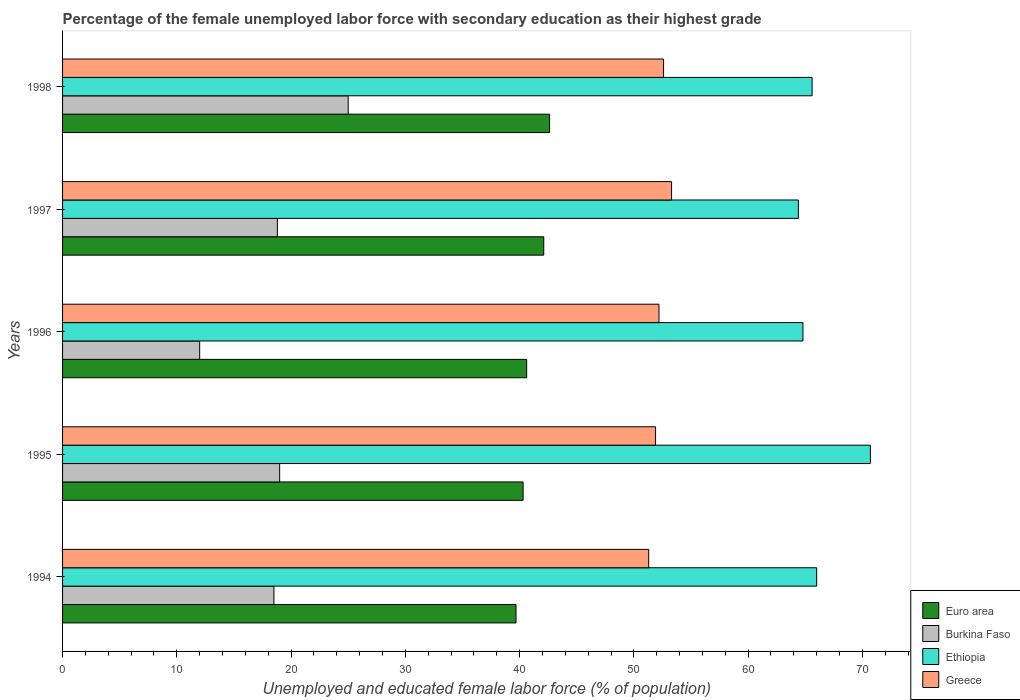How many groups of bars are there?
Ensure brevity in your answer.  5. Are the number of bars per tick equal to the number of legend labels?
Offer a terse response. Yes. How many bars are there on the 4th tick from the bottom?
Keep it short and to the point. 4. What is the label of the 4th group of bars from the top?
Offer a terse response. 1995. Across all years, what is the maximum percentage of the unemployed female labor force with secondary education in Greece?
Your answer should be compact. 53.3. Across all years, what is the minimum percentage of the unemployed female labor force with secondary education in Burkina Faso?
Make the answer very short. 12. In which year was the percentage of the unemployed female labor force with secondary education in Burkina Faso maximum?
Give a very brief answer. 1998. In which year was the percentage of the unemployed female labor force with secondary education in Greece minimum?
Offer a terse response. 1994. What is the total percentage of the unemployed female labor force with secondary education in Euro area in the graph?
Provide a short and direct response. 205.35. What is the difference between the percentage of the unemployed female labor force with secondary education in Euro area in 1994 and that in 1997?
Offer a very short reply. -2.43. What is the difference between the percentage of the unemployed female labor force with secondary education in Euro area in 1996 and the percentage of the unemployed female labor force with secondary education in Burkina Faso in 1997?
Your response must be concise. 21.82. What is the average percentage of the unemployed female labor force with secondary education in Euro area per year?
Provide a short and direct response. 41.07. In the year 1996, what is the difference between the percentage of the unemployed female labor force with secondary education in Euro area and percentage of the unemployed female labor force with secondary education in Burkina Faso?
Your answer should be very brief. 28.62. In how many years, is the percentage of the unemployed female labor force with secondary education in Greece greater than 2 %?
Give a very brief answer. 5. What is the ratio of the percentage of the unemployed female labor force with secondary education in Euro area in 1994 to that in 1996?
Provide a succinct answer. 0.98. What is the difference between the highest and the second highest percentage of the unemployed female labor force with secondary education in Burkina Faso?
Your response must be concise. 6. Is the sum of the percentage of the unemployed female labor force with secondary education in Greece in 1994 and 1997 greater than the maximum percentage of the unemployed female labor force with secondary education in Euro area across all years?
Give a very brief answer. Yes. Is it the case that in every year, the sum of the percentage of the unemployed female labor force with secondary education in Burkina Faso and percentage of the unemployed female labor force with secondary education in Ethiopia is greater than the sum of percentage of the unemployed female labor force with secondary education in Greece and percentage of the unemployed female labor force with secondary education in Euro area?
Ensure brevity in your answer.  Yes. What does the 2nd bar from the top in 1997 represents?
Keep it short and to the point. Ethiopia. What does the 3rd bar from the bottom in 1995 represents?
Your answer should be compact. Ethiopia. Is it the case that in every year, the sum of the percentage of the unemployed female labor force with secondary education in Ethiopia and percentage of the unemployed female labor force with secondary education in Burkina Faso is greater than the percentage of the unemployed female labor force with secondary education in Greece?
Your answer should be very brief. Yes. How many years are there in the graph?
Your response must be concise. 5. How are the legend labels stacked?
Ensure brevity in your answer.  Vertical. What is the title of the graph?
Your answer should be very brief. Percentage of the female unemployed labor force with secondary education as their highest grade. Does "Saudi Arabia" appear as one of the legend labels in the graph?
Your answer should be compact. No. What is the label or title of the X-axis?
Ensure brevity in your answer.  Unemployed and educated female labor force (% of population). What is the Unemployed and educated female labor force (% of population) of Euro area in 1994?
Give a very brief answer. 39.69. What is the Unemployed and educated female labor force (% of population) in Burkina Faso in 1994?
Offer a terse response. 18.5. What is the Unemployed and educated female labor force (% of population) in Greece in 1994?
Your answer should be compact. 51.3. What is the Unemployed and educated female labor force (% of population) of Euro area in 1995?
Offer a terse response. 40.31. What is the Unemployed and educated female labor force (% of population) in Ethiopia in 1995?
Give a very brief answer. 70.7. What is the Unemployed and educated female labor force (% of population) of Greece in 1995?
Offer a terse response. 51.9. What is the Unemployed and educated female labor force (% of population) of Euro area in 1996?
Make the answer very short. 40.62. What is the Unemployed and educated female labor force (% of population) of Ethiopia in 1996?
Your answer should be compact. 64.8. What is the Unemployed and educated female labor force (% of population) in Greece in 1996?
Provide a succinct answer. 52.2. What is the Unemployed and educated female labor force (% of population) of Euro area in 1997?
Make the answer very short. 42.11. What is the Unemployed and educated female labor force (% of population) of Burkina Faso in 1997?
Ensure brevity in your answer.  18.8. What is the Unemployed and educated female labor force (% of population) of Ethiopia in 1997?
Keep it short and to the point. 64.4. What is the Unemployed and educated female labor force (% of population) of Greece in 1997?
Give a very brief answer. 53.3. What is the Unemployed and educated female labor force (% of population) of Euro area in 1998?
Your answer should be very brief. 42.63. What is the Unemployed and educated female labor force (% of population) in Burkina Faso in 1998?
Your response must be concise. 25. What is the Unemployed and educated female labor force (% of population) of Ethiopia in 1998?
Provide a succinct answer. 65.6. What is the Unemployed and educated female labor force (% of population) in Greece in 1998?
Your response must be concise. 52.6. Across all years, what is the maximum Unemployed and educated female labor force (% of population) in Euro area?
Provide a short and direct response. 42.63. Across all years, what is the maximum Unemployed and educated female labor force (% of population) of Burkina Faso?
Make the answer very short. 25. Across all years, what is the maximum Unemployed and educated female labor force (% of population) of Ethiopia?
Provide a short and direct response. 70.7. Across all years, what is the maximum Unemployed and educated female labor force (% of population) in Greece?
Offer a terse response. 53.3. Across all years, what is the minimum Unemployed and educated female labor force (% of population) in Euro area?
Offer a terse response. 39.69. Across all years, what is the minimum Unemployed and educated female labor force (% of population) in Ethiopia?
Your response must be concise. 64.4. Across all years, what is the minimum Unemployed and educated female labor force (% of population) of Greece?
Provide a short and direct response. 51.3. What is the total Unemployed and educated female labor force (% of population) in Euro area in the graph?
Provide a short and direct response. 205.35. What is the total Unemployed and educated female labor force (% of population) in Burkina Faso in the graph?
Offer a terse response. 93.3. What is the total Unemployed and educated female labor force (% of population) in Ethiopia in the graph?
Your answer should be very brief. 331.5. What is the total Unemployed and educated female labor force (% of population) of Greece in the graph?
Your answer should be very brief. 261.3. What is the difference between the Unemployed and educated female labor force (% of population) in Euro area in 1994 and that in 1995?
Provide a short and direct response. -0.62. What is the difference between the Unemployed and educated female labor force (% of population) in Ethiopia in 1994 and that in 1995?
Your answer should be very brief. -4.7. What is the difference between the Unemployed and educated female labor force (% of population) in Euro area in 1994 and that in 1996?
Your response must be concise. -0.93. What is the difference between the Unemployed and educated female labor force (% of population) of Euro area in 1994 and that in 1997?
Offer a very short reply. -2.43. What is the difference between the Unemployed and educated female labor force (% of population) in Ethiopia in 1994 and that in 1997?
Make the answer very short. 1.6. What is the difference between the Unemployed and educated female labor force (% of population) of Euro area in 1994 and that in 1998?
Offer a very short reply. -2.94. What is the difference between the Unemployed and educated female labor force (% of population) of Ethiopia in 1994 and that in 1998?
Your answer should be very brief. 0.4. What is the difference between the Unemployed and educated female labor force (% of population) in Euro area in 1995 and that in 1996?
Your answer should be compact. -0.31. What is the difference between the Unemployed and educated female labor force (% of population) of Burkina Faso in 1995 and that in 1996?
Your answer should be compact. 7. What is the difference between the Unemployed and educated female labor force (% of population) in Ethiopia in 1995 and that in 1996?
Keep it short and to the point. 5.9. What is the difference between the Unemployed and educated female labor force (% of population) of Euro area in 1995 and that in 1997?
Make the answer very short. -1.81. What is the difference between the Unemployed and educated female labor force (% of population) of Burkina Faso in 1995 and that in 1997?
Provide a succinct answer. 0.2. What is the difference between the Unemployed and educated female labor force (% of population) of Greece in 1995 and that in 1997?
Your answer should be very brief. -1.4. What is the difference between the Unemployed and educated female labor force (% of population) in Euro area in 1995 and that in 1998?
Your answer should be compact. -2.32. What is the difference between the Unemployed and educated female labor force (% of population) in Ethiopia in 1995 and that in 1998?
Provide a short and direct response. 5.1. What is the difference between the Unemployed and educated female labor force (% of population) of Euro area in 1996 and that in 1997?
Your answer should be compact. -1.49. What is the difference between the Unemployed and educated female labor force (% of population) of Burkina Faso in 1996 and that in 1997?
Provide a short and direct response. -6.8. What is the difference between the Unemployed and educated female labor force (% of population) of Euro area in 1996 and that in 1998?
Provide a short and direct response. -2.01. What is the difference between the Unemployed and educated female labor force (% of population) of Burkina Faso in 1996 and that in 1998?
Provide a short and direct response. -13. What is the difference between the Unemployed and educated female labor force (% of population) in Ethiopia in 1996 and that in 1998?
Give a very brief answer. -0.8. What is the difference between the Unemployed and educated female labor force (% of population) of Euro area in 1997 and that in 1998?
Provide a short and direct response. -0.51. What is the difference between the Unemployed and educated female labor force (% of population) in Burkina Faso in 1997 and that in 1998?
Provide a succinct answer. -6.2. What is the difference between the Unemployed and educated female labor force (% of population) of Greece in 1997 and that in 1998?
Ensure brevity in your answer.  0.7. What is the difference between the Unemployed and educated female labor force (% of population) in Euro area in 1994 and the Unemployed and educated female labor force (% of population) in Burkina Faso in 1995?
Make the answer very short. 20.69. What is the difference between the Unemployed and educated female labor force (% of population) of Euro area in 1994 and the Unemployed and educated female labor force (% of population) of Ethiopia in 1995?
Offer a terse response. -31.01. What is the difference between the Unemployed and educated female labor force (% of population) in Euro area in 1994 and the Unemployed and educated female labor force (% of population) in Greece in 1995?
Offer a very short reply. -12.21. What is the difference between the Unemployed and educated female labor force (% of population) in Burkina Faso in 1994 and the Unemployed and educated female labor force (% of population) in Ethiopia in 1995?
Give a very brief answer. -52.2. What is the difference between the Unemployed and educated female labor force (% of population) in Burkina Faso in 1994 and the Unemployed and educated female labor force (% of population) in Greece in 1995?
Your answer should be very brief. -33.4. What is the difference between the Unemployed and educated female labor force (% of population) in Ethiopia in 1994 and the Unemployed and educated female labor force (% of population) in Greece in 1995?
Make the answer very short. 14.1. What is the difference between the Unemployed and educated female labor force (% of population) in Euro area in 1994 and the Unemployed and educated female labor force (% of population) in Burkina Faso in 1996?
Offer a very short reply. 27.69. What is the difference between the Unemployed and educated female labor force (% of population) of Euro area in 1994 and the Unemployed and educated female labor force (% of population) of Ethiopia in 1996?
Ensure brevity in your answer.  -25.11. What is the difference between the Unemployed and educated female labor force (% of population) of Euro area in 1994 and the Unemployed and educated female labor force (% of population) of Greece in 1996?
Give a very brief answer. -12.51. What is the difference between the Unemployed and educated female labor force (% of population) in Burkina Faso in 1994 and the Unemployed and educated female labor force (% of population) in Ethiopia in 1996?
Provide a short and direct response. -46.3. What is the difference between the Unemployed and educated female labor force (% of population) in Burkina Faso in 1994 and the Unemployed and educated female labor force (% of population) in Greece in 1996?
Your response must be concise. -33.7. What is the difference between the Unemployed and educated female labor force (% of population) of Ethiopia in 1994 and the Unemployed and educated female labor force (% of population) of Greece in 1996?
Your answer should be compact. 13.8. What is the difference between the Unemployed and educated female labor force (% of population) of Euro area in 1994 and the Unemployed and educated female labor force (% of population) of Burkina Faso in 1997?
Make the answer very short. 20.89. What is the difference between the Unemployed and educated female labor force (% of population) in Euro area in 1994 and the Unemployed and educated female labor force (% of population) in Ethiopia in 1997?
Your answer should be very brief. -24.71. What is the difference between the Unemployed and educated female labor force (% of population) of Euro area in 1994 and the Unemployed and educated female labor force (% of population) of Greece in 1997?
Offer a terse response. -13.61. What is the difference between the Unemployed and educated female labor force (% of population) in Burkina Faso in 1994 and the Unemployed and educated female labor force (% of population) in Ethiopia in 1997?
Keep it short and to the point. -45.9. What is the difference between the Unemployed and educated female labor force (% of population) of Burkina Faso in 1994 and the Unemployed and educated female labor force (% of population) of Greece in 1997?
Offer a terse response. -34.8. What is the difference between the Unemployed and educated female labor force (% of population) of Ethiopia in 1994 and the Unemployed and educated female labor force (% of population) of Greece in 1997?
Provide a short and direct response. 12.7. What is the difference between the Unemployed and educated female labor force (% of population) in Euro area in 1994 and the Unemployed and educated female labor force (% of population) in Burkina Faso in 1998?
Make the answer very short. 14.69. What is the difference between the Unemployed and educated female labor force (% of population) in Euro area in 1994 and the Unemployed and educated female labor force (% of population) in Ethiopia in 1998?
Your response must be concise. -25.91. What is the difference between the Unemployed and educated female labor force (% of population) in Euro area in 1994 and the Unemployed and educated female labor force (% of population) in Greece in 1998?
Your answer should be very brief. -12.91. What is the difference between the Unemployed and educated female labor force (% of population) in Burkina Faso in 1994 and the Unemployed and educated female labor force (% of population) in Ethiopia in 1998?
Give a very brief answer. -47.1. What is the difference between the Unemployed and educated female labor force (% of population) of Burkina Faso in 1994 and the Unemployed and educated female labor force (% of population) of Greece in 1998?
Provide a short and direct response. -34.1. What is the difference between the Unemployed and educated female labor force (% of population) in Euro area in 1995 and the Unemployed and educated female labor force (% of population) in Burkina Faso in 1996?
Your answer should be compact. 28.31. What is the difference between the Unemployed and educated female labor force (% of population) of Euro area in 1995 and the Unemployed and educated female labor force (% of population) of Ethiopia in 1996?
Give a very brief answer. -24.49. What is the difference between the Unemployed and educated female labor force (% of population) of Euro area in 1995 and the Unemployed and educated female labor force (% of population) of Greece in 1996?
Your answer should be compact. -11.89. What is the difference between the Unemployed and educated female labor force (% of population) of Burkina Faso in 1995 and the Unemployed and educated female labor force (% of population) of Ethiopia in 1996?
Offer a very short reply. -45.8. What is the difference between the Unemployed and educated female labor force (% of population) in Burkina Faso in 1995 and the Unemployed and educated female labor force (% of population) in Greece in 1996?
Offer a very short reply. -33.2. What is the difference between the Unemployed and educated female labor force (% of population) of Euro area in 1995 and the Unemployed and educated female labor force (% of population) of Burkina Faso in 1997?
Keep it short and to the point. 21.51. What is the difference between the Unemployed and educated female labor force (% of population) of Euro area in 1995 and the Unemployed and educated female labor force (% of population) of Ethiopia in 1997?
Keep it short and to the point. -24.09. What is the difference between the Unemployed and educated female labor force (% of population) in Euro area in 1995 and the Unemployed and educated female labor force (% of population) in Greece in 1997?
Offer a very short reply. -12.99. What is the difference between the Unemployed and educated female labor force (% of population) of Burkina Faso in 1995 and the Unemployed and educated female labor force (% of population) of Ethiopia in 1997?
Your answer should be very brief. -45.4. What is the difference between the Unemployed and educated female labor force (% of population) of Burkina Faso in 1995 and the Unemployed and educated female labor force (% of population) of Greece in 1997?
Make the answer very short. -34.3. What is the difference between the Unemployed and educated female labor force (% of population) in Euro area in 1995 and the Unemployed and educated female labor force (% of population) in Burkina Faso in 1998?
Your response must be concise. 15.31. What is the difference between the Unemployed and educated female labor force (% of population) in Euro area in 1995 and the Unemployed and educated female labor force (% of population) in Ethiopia in 1998?
Your response must be concise. -25.29. What is the difference between the Unemployed and educated female labor force (% of population) in Euro area in 1995 and the Unemployed and educated female labor force (% of population) in Greece in 1998?
Your answer should be very brief. -12.29. What is the difference between the Unemployed and educated female labor force (% of population) in Burkina Faso in 1995 and the Unemployed and educated female labor force (% of population) in Ethiopia in 1998?
Make the answer very short. -46.6. What is the difference between the Unemployed and educated female labor force (% of population) of Burkina Faso in 1995 and the Unemployed and educated female labor force (% of population) of Greece in 1998?
Make the answer very short. -33.6. What is the difference between the Unemployed and educated female labor force (% of population) of Ethiopia in 1995 and the Unemployed and educated female labor force (% of population) of Greece in 1998?
Keep it short and to the point. 18.1. What is the difference between the Unemployed and educated female labor force (% of population) in Euro area in 1996 and the Unemployed and educated female labor force (% of population) in Burkina Faso in 1997?
Keep it short and to the point. 21.82. What is the difference between the Unemployed and educated female labor force (% of population) of Euro area in 1996 and the Unemployed and educated female labor force (% of population) of Ethiopia in 1997?
Your answer should be very brief. -23.78. What is the difference between the Unemployed and educated female labor force (% of population) in Euro area in 1996 and the Unemployed and educated female labor force (% of population) in Greece in 1997?
Ensure brevity in your answer.  -12.68. What is the difference between the Unemployed and educated female labor force (% of population) of Burkina Faso in 1996 and the Unemployed and educated female labor force (% of population) of Ethiopia in 1997?
Provide a succinct answer. -52.4. What is the difference between the Unemployed and educated female labor force (% of population) of Burkina Faso in 1996 and the Unemployed and educated female labor force (% of population) of Greece in 1997?
Your answer should be very brief. -41.3. What is the difference between the Unemployed and educated female labor force (% of population) in Euro area in 1996 and the Unemployed and educated female labor force (% of population) in Burkina Faso in 1998?
Make the answer very short. 15.62. What is the difference between the Unemployed and educated female labor force (% of population) of Euro area in 1996 and the Unemployed and educated female labor force (% of population) of Ethiopia in 1998?
Your answer should be very brief. -24.98. What is the difference between the Unemployed and educated female labor force (% of population) of Euro area in 1996 and the Unemployed and educated female labor force (% of population) of Greece in 1998?
Your answer should be compact. -11.98. What is the difference between the Unemployed and educated female labor force (% of population) of Burkina Faso in 1996 and the Unemployed and educated female labor force (% of population) of Ethiopia in 1998?
Give a very brief answer. -53.6. What is the difference between the Unemployed and educated female labor force (% of population) of Burkina Faso in 1996 and the Unemployed and educated female labor force (% of population) of Greece in 1998?
Make the answer very short. -40.6. What is the difference between the Unemployed and educated female labor force (% of population) in Ethiopia in 1996 and the Unemployed and educated female labor force (% of population) in Greece in 1998?
Offer a terse response. 12.2. What is the difference between the Unemployed and educated female labor force (% of population) of Euro area in 1997 and the Unemployed and educated female labor force (% of population) of Burkina Faso in 1998?
Give a very brief answer. 17.11. What is the difference between the Unemployed and educated female labor force (% of population) of Euro area in 1997 and the Unemployed and educated female labor force (% of population) of Ethiopia in 1998?
Your answer should be compact. -23.49. What is the difference between the Unemployed and educated female labor force (% of population) of Euro area in 1997 and the Unemployed and educated female labor force (% of population) of Greece in 1998?
Ensure brevity in your answer.  -10.49. What is the difference between the Unemployed and educated female labor force (% of population) in Burkina Faso in 1997 and the Unemployed and educated female labor force (% of population) in Ethiopia in 1998?
Provide a succinct answer. -46.8. What is the difference between the Unemployed and educated female labor force (% of population) in Burkina Faso in 1997 and the Unemployed and educated female labor force (% of population) in Greece in 1998?
Give a very brief answer. -33.8. What is the difference between the Unemployed and educated female labor force (% of population) of Ethiopia in 1997 and the Unemployed and educated female labor force (% of population) of Greece in 1998?
Provide a succinct answer. 11.8. What is the average Unemployed and educated female labor force (% of population) of Euro area per year?
Give a very brief answer. 41.07. What is the average Unemployed and educated female labor force (% of population) of Burkina Faso per year?
Give a very brief answer. 18.66. What is the average Unemployed and educated female labor force (% of population) in Ethiopia per year?
Make the answer very short. 66.3. What is the average Unemployed and educated female labor force (% of population) in Greece per year?
Offer a terse response. 52.26. In the year 1994, what is the difference between the Unemployed and educated female labor force (% of population) of Euro area and Unemployed and educated female labor force (% of population) of Burkina Faso?
Your answer should be very brief. 21.19. In the year 1994, what is the difference between the Unemployed and educated female labor force (% of population) in Euro area and Unemployed and educated female labor force (% of population) in Ethiopia?
Ensure brevity in your answer.  -26.31. In the year 1994, what is the difference between the Unemployed and educated female labor force (% of population) of Euro area and Unemployed and educated female labor force (% of population) of Greece?
Keep it short and to the point. -11.61. In the year 1994, what is the difference between the Unemployed and educated female labor force (% of population) in Burkina Faso and Unemployed and educated female labor force (% of population) in Ethiopia?
Your response must be concise. -47.5. In the year 1994, what is the difference between the Unemployed and educated female labor force (% of population) in Burkina Faso and Unemployed and educated female labor force (% of population) in Greece?
Offer a very short reply. -32.8. In the year 1994, what is the difference between the Unemployed and educated female labor force (% of population) in Ethiopia and Unemployed and educated female labor force (% of population) in Greece?
Offer a very short reply. 14.7. In the year 1995, what is the difference between the Unemployed and educated female labor force (% of population) in Euro area and Unemployed and educated female labor force (% of population) in Burkina Faso?
Provide a short and direct response. 21.31. In the year 1995, what is the difference between the Unemployed and educated female labor force (% of population) of Euro area and Unemployed and educated female labor force (% of population) of Ethiopia?
Make the answer very short. -30.39. In the year 1995, what is the difference between the Unemployed and educated female labor force (% of population) in Euro area and Unemployed and educated female labor force (% of population) in Greece?
Offer a very short reply. -11.59. In the year 1995, what is the difference between the Unemployed and educated female labor force (% of population) in Burkina Faso and Unemployed and educated female labor force (% of population) in Ethiopia?
Provide a short and direct response. -51.7. In the year 1995, what is the difference between the Unemployed and educated female labor force (% of population) of Burkina Faso and Unemployed and educated female labor force (% of population) of Greece?
Offer a very short reply. -32.9. In the year 1996, what is the difference between the Unemployed and educated female labor force (% of population) in Euro area and Unemployed and educated female labor force (% of population) in Burkina Faso?
Offer a terse response. 28.62. In the year 1996, what is the difference between the Unemployed and educated female labor force (% of population) in Euro area and Unemployed and educated female labor force (% of population) in Ethiopia?
Your answer should be compact. -24.18. In the year 1996, what is the difference between the Unemployed and educated female labor force (% of population) in Euro area and Unemployed and educated female labor force (% of population) in Greece?
Your answer should be very brief. -11.58. In the year 1996, what is the difference between the Unemployed and educated female labor force (% of population) of Burkina Faso and Unemployed and educated female labor force (% of population) of Ethiopia?
Your answer should be very brief. -52.8. In the year 1996, what is the difference between the Unemployed and educated female labor force (% of population) in Burkina Faso and Unemployed and educated female labor force (% of population) in Greece?
Ensure brevity in your answer.  -40.2. In the year 1996, what is the difference between the Unemployed and educated female labor force (% of population) in Ethiopia and Unemployed and educated female labor force (% of population) in Greece?
Offer a very short reply. 12.6. In the year 1997, what is the difference between the Unemployed and educated female labor force (% of population) of Euro area and Unemployed and educated female labor force (% of population) of Burkina Faso?
Your answer should be very brief. 23.31. In the year 1997, what is the difference between the Unemployed and educated female labor force (% of population) of Euro area and Unemployed and educated female labor force (% of population) of Ethiopia?
Offer a terse response. -22.29. In the year 1997, what is the difference between the Unemployed and educated female labor force (% of population) of Euro area and Unemployed and educated female labor force (% of population) of Greece?
Your answer should be very brief. -11.19. In the year 1997, what is the difference between the Unemployed and educated female labor force (% of population) of Burkina Faso and Unemployed and educated female labor force (% of population) of Ethiopia?
Your response must be concise. -45.6. In the year 1997, what is the difference between the Unemployed and educated female labor force (% of population) in Burkina Faso and Unemployed and educated female labor force (% of population) in Greece?
Your answer should be very brief. -34.5. In the year 1998, what is the difference between the Unemployed and educated female labor force (% of population) in Euro area and Unemployed and educated female labor force (% of population) in Burkina Faso?
Give a very brief answer. 17.63. In the year 1998, what is the difference between the Unemployed and educated female labor force (% of population) in Euro area and Unemployed and educated female labor force (% of population) in Ethiopia?
Keep it short and to the point. -22.97. In the year 1998, what is the difference between the Unemployed and educated female labor force (% of population) of Euro area and Unemployed and educated female labor force (% of population) of Greece?
Keep it short and to the point. -9.97. In the year 1998, what is the difference between the Unemployed and educated female labor force (% of population) in Burkina Faso and Unemployed and educated female labor force (% of population) in Ethiopia?
Provide a succinct answer. -40.6. In the year 1998, what is the difference between the Unemployed and educated female labor force (% of population) of Burkina Faso and Unemployed and educated female labor force (% of population) of Greece?
Give a very brief answer. -27.6. In the year 1998, what is the difference between the Unemployed and educated female labor force (% of population) of Ethiopia and Unemployed and educated female labor force (% of population) of Greece?
Provide a short and direct response. 13. What is the ratio of the Unemployed and educated female labor force (% of population) of Euro area in 1994 to that in 1995?
Make the answer very short. 0.98. What is the ratio of the Unemployed and educated female labor force (% of population) of Burkina Faso in 1994 to that in 1995?
Ensure brevity in your answer.  0.97. What is the ratio of the Unemployed and educated female labor force (% of population) in Ethiopia in 1994 to that in 1995?
Ensure brevity in your answer.  0.93. What is the ratio of the Unemployed and educated female labor force (% of population) of Greece in 1994 to that in 1995?
Keep it short and to the point. 0.99. What is the ratio of the Unemployed and educated female labor force (% of population) in Euro area in 1994 to that in 1996?
Ensure brevity in your answer.  0.98. What is the ratio of the Unemployed and educated female labor force (% of population) in Burkina Faso in 1994 to that in 1996?
Provide a short and direct response. 1.54. What is the ratio of the Unemployed and educated female labor force (% of population) in Ethiopia in 1994 to that in 1996?
Your answer should be very brief. 1.02. What is the ratio of the Unemployed and educated female labor force (% of population) in Greece in 1994 to that in 1996?
Offer a terse response. 0.98. What is the ratio of the Unemployed and educated female labor force (% of population) of Euro area in 1994 to that in 1997?
Your response must be concise. 0.94. What is the ratio of the Unemployed and educated female labor force (% of population) in Ethiopia in 1994 to that in 1997?
Your answer should be compact. 1.02. What is the ratio of the Unemployed and educated female labor force (% of population) in Greece in 1994 to that in 1997?
Your answer should be very brief. 0.96. What is the ratio of the Unemployed and educated female labor force (% of population) in Burkina Faso in 1994 to that in 1998?
Keep it short and to the point. 0.74. What is the ratio of the Unemployed and educated female labor force (% of population) of Ethiopia in 1994 to that in 1998?
Offer a very short reply. 1.01. What is the ratio of the Unemployed and educated female labor force (% of population) of Greece in 1994 to that in 1998?
Give a very brief answer. 0.98. What is the ratio of the Unemployed and educated female labor force (% of population) in Euro area in 1995 to that in 1996?
Make the answer very short. 0.99. What is the ratio of the Unemployed and educated female labor force (% of population) in Burkina Faso in 1995 to that in 1996?
Provide a short and direct response. 1.58. What is the ratio of the Unemployed and educated female labor force (% of population) of Ethiopia in 1995 to that in 1996?
Make the answer very short. 1.09. What is the ratio of the Unemployed and educated female labor force (% of population) of Greece in 1995 to that in 1996?
Your answer should be very brief. 0.99. What is the ratio of the Unemployed and educated female labor force (% of population) in Euro area in 1995 to that in 1997?
Your response must be concise. 0.96. What is the ratio of the Unemployed and educated female labor force (% of population) of Burkina Faso in 1995 to that in 1997?
Offer a terse response. 1.01. What is the ratio of the Unemployed and educated female labor force (% of population) in Ethiopia in 1995 to that in 1997?
Your answer should be compact. 1.1. What is the ratio of the Unemployed and educated female labor force (% of population) in Greece in 1995 to that in 1997?
Give a very brief answer. 0.97. What is the ratio of the Unemployed and educated female labor force (% of population) of Euro area in 1995 to that in 1998?
Offer a very short reply. 0.95. What is the ratio of the Unemployed and educated female labor force (% of population) of Burkina Faso in 1995 to that in 1998?
Keep it short and to the point. 0.76. What is the ratio of the Unemployed and educated female labor force (% of population) in Ethiopia in 1995 to that in 1998?
Your answer should be compact. 1.08. What is the ratio of the Unemployed and educated female labor force (% of population) in Greece in 1995 to that in 1998?
Your answer should be compact. 0.99. What is the ratio of the Unemployed and educated female labor force (% of population) of Euro area in 1996 to that in 1997?
Offer a terse response. 0.96. What is the ratio of the Unemployed and educated female labor force (% of population) of Burkina Faso in 1996 to that in 1997?
Provide a short and direct response. 0.64. What is the ratio of the Unemployed and educated female labor force (% of population) of Ethiopia in 1996 to that in 1997?
Your answer should be compact. 1.01. What is the ratio of the Unemployed and educated female labor force (% of population) in Greece in 1996 to that in 1997?
Provide a short and direct response. 0.98. What is the ratio of the Unemployed and educated female labor force (% of population) in Euro area in 1996 to that in 1998?
Make the answer very short. 0.95. What is the ratio of the Unemployed and educated female labor force (% of population) in Burkina Faso in 1996 to that in 1998?
Keep it short and to the point. 0.48. What is the ratio of the Unemployed and educated female labor force (% of population) of Ethiopia in 1996 to that in 1998?
Provide a succinct answer. 0.99. What is the ratio of the Unemployed and educated female labor force (% of population) of Euro area in 1997 to that in 1998?
Provide a succinct answer. 0.99. What is the ratio of the Unemployed and educated female labor force (% of population) of Burkina Faso in 1997 to that in 1998?
Give a very brief answer. 0.75. What is the ratio of the Unemployed and educated female labor force (% of population) in Ethiopia in 1997 to that in 1998?
Provide a succinct answer. 0.98. What is the ratio of the Unemployed and educated female labor force (% of population) of Greece in 1997 to that in 1998?
Your response must be concise. 1.01. What is the difference between the highest and the second highest Unemployed and educated female labor force (% of population) of Euro area?
Your answer should be very brief. 0.51. What is the difference between the highest and the lowest Unemployed and educated female labor force (% of population) of Euro area?
Give a very brief answer. 2.94. What is the difference between the highest and the lowest Unemployed and educated female labor force (% of population) of Burkina Faso?
Keep it short and to the point. 13. What is the difference between the highest and the lowest Unemployed and educated female labor force (% of population) of Ethiopia?
Your answer should be compact. 6.3. What is the difference between the highest and the lowest Unemployed and educated female labor force (% of population) of Greece?
Give a very brief answer. 2. 